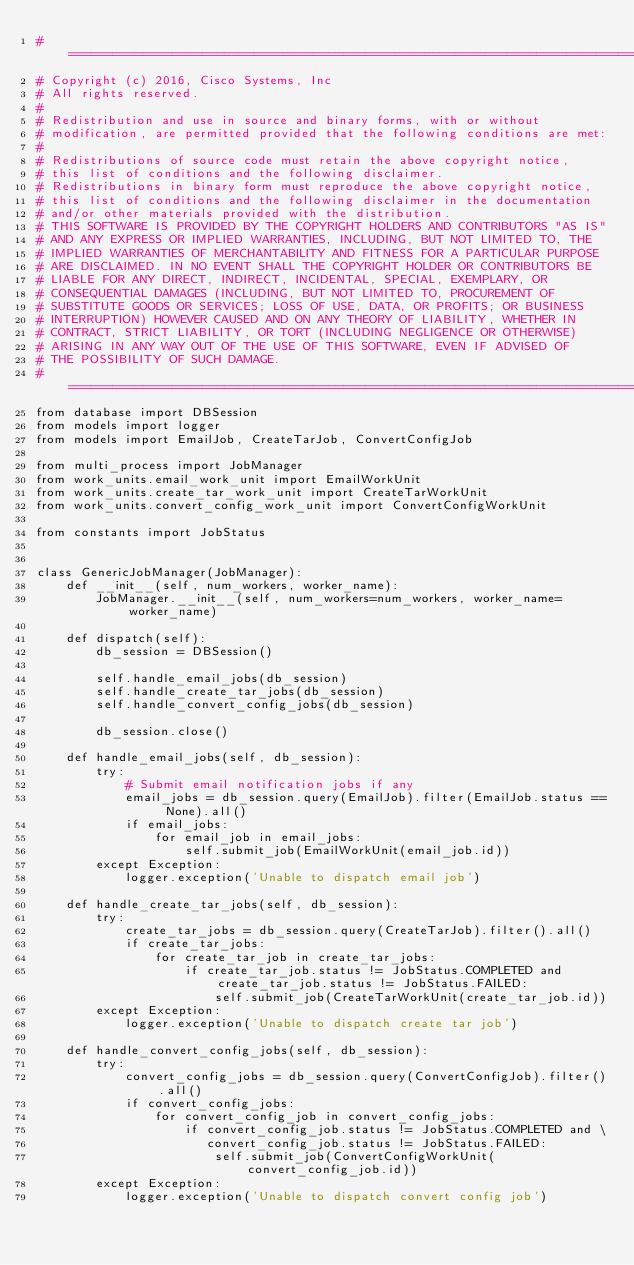Convert code to text. <code><loc_0><loc_0><loc_500><loc_500><_Python_># =============================================================================
# Copyright (c) 2016, Cisco Systems, Inc
# All rights reserved.
#
# Redistribution and use in source and binary forms, with or without
# modification, are permitted provided that the following conditions are met:
#
# Redistributions of source code must retain the above copyright notice,
# this list of conditions and the following disclaimer.
# Redistributions in binary form must reproduce the above copyright notice,
# this list of conditions and the following disclaimer in the documentation
# and/or other materials provided with the distribution.
# THIS SOFTWARE IS PROVIDED BY THE COPYRIGHT HOLDERS AND CONTRIBUTORS "AS IS"
# AND ANY EXPRESS OR IMPLIED WARRANTIES, INCLUDING, BUT NOT LIMITED TO, THE
# IMPLIED WARRANTIES OF MERCHANTABILITY AND FITNESS FOR A PARTICULAR PURPOSE
# ARE DISCLAIMED. IN NO EVENT SHALL THE COPYRIGHT HOLDER OR CONTRIBUTORS BE
# LIABLE FOR ANY DIRECT, INDIRECT, INCIDENTAL, SPECIAL, EXEMPLARY, OR
# CONSEQUENTIAL DAMAGES (INCLUDING, BUT NOT LIMITED TO, PROCUREMENT OF
# SUBSTITUTE GOODS OR SERVICES; LOSS OF USE, DATA, OR PROFITS; OR BUSINESS
# INTERRUPTION) HOWEVER CAUSED AND ON ANY THEORY OF LIABILITY, WHETHER IN
# CONTRACT, STRICT LIABILITY, OR TORT (INCLUDING NEGLIGENCE OR OTHERWISE)
# ARISING IN ANY WAY OUT OF THE USE OF THIS SOFTWARE, EVEN IF ADVISED OF
# THE POSSIBILITY OF SUCH DAMAGE.
# =============================================================================
from database import DBSession
from models import logger
from models import EmailJob, CreateTarJob, ConvertConfigJob

from multi_process import JobManager
from work_units.email_work_unit import EmailWorkUnit
from work_units.create_tar_work_unit import CreateTarWorkUnit
from work_units.convert_config_work_unit import ConvertConfigWorkUnit

from constants import JobStatus


class GenericJobManager(JobManager):
    def __init__(self, num_workers, worker_name):
        JobManager.__init__(self, num_workers=num_workers, worker_name=worker_name)

    def dispatch(self):
        db_session = DBSession()

        self.handle_email_jobs(db_session)
        self.handle_create_tar_jobs(db_session)
        self.handle_convert_config_jobs(db_session)

        db_session.close()

    def handle_email_jobs(self, db_session):
        try:
            # Submit email notification jobs if any
            email_jobs = db_session.query(EmailJob).filter(EmailJob.status == None).all()
            if email_jobs:
                for email_job in email_jobs:
                    self.submit_job(EmailWorkUnit(email_job.id))
        except Exception:
            logger.exception('Unable to dispatch email job')

    def handle_create_tar_jobs(self, db_session):
        try:
            create_tar_jobs = db_session.query(CreateTarJob).filter().all()
            if create_tar_jobs:
                for create_tar_job in create_tar_jobs:
                    if create_tar_job.status != JobStatus.COMPLETED and create_tar_job.status != JobStatus.FAILED:
                        self.submit_job(CreateTarWorkUnit(create_tar_job.id))
        except Exception:
            logger.exception('Unable to dispatch create tar job')

    def handle_convert_config_jobs(self, db_session):
        try:
            convert_config_jobs = db_session.query(ConvertConfigJob).filter().all()
            if convert_config_jobs:
                for convert_config_job in convert_config_jobs:
                    if convert_config_job.status != JobStatus.COMPLETED and \
                       convert_config_job.status != JobStatus.FAILED:
                        self.submit_job(ConvertConfigWorkUnit(convert_config_job.id))
        except Exception:
            logger.exception('Unable to dispatch convert config job')
</code> 